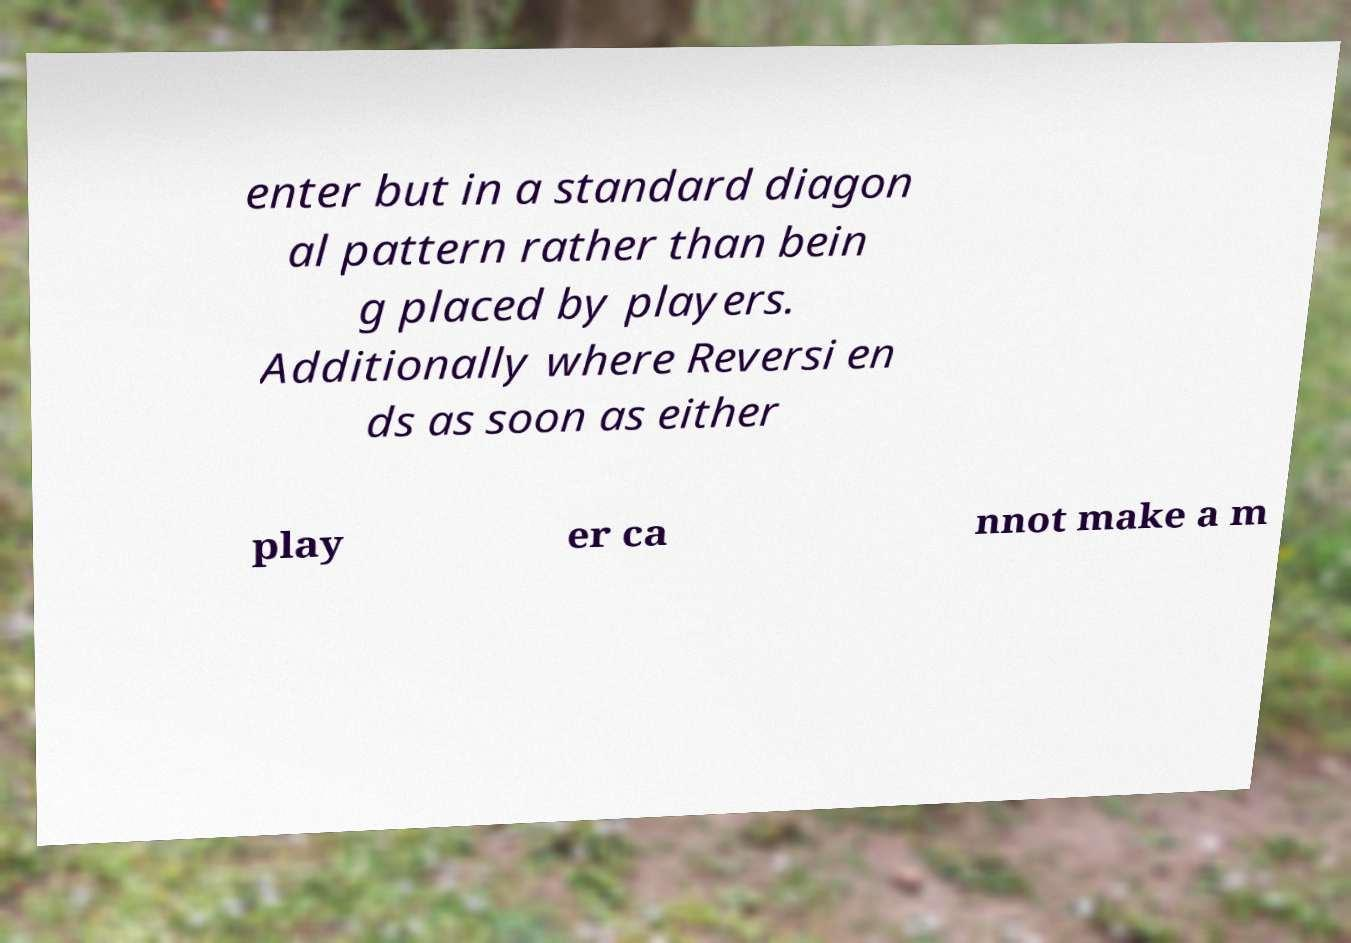Could you extract and type out the text from this image? enter but in a standard diagon al pattern rather than bein g placed by players. Additionally where Reversi en ds as soon as either play er ca nnot make a m 